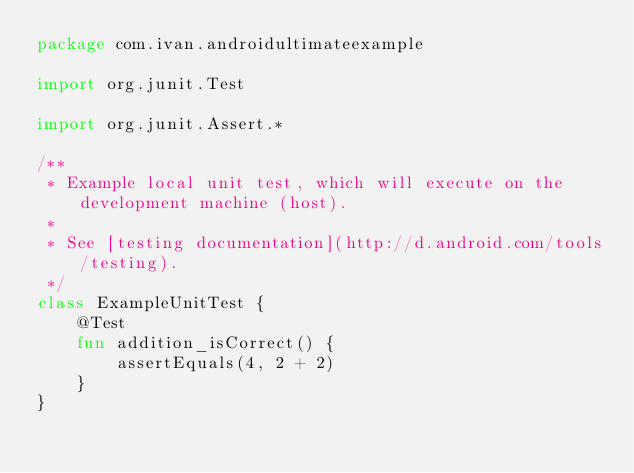<code> <loc_0><loc_0><loc_500><loc_500><_Kotlin_>package com.ivan.androidultimateexample

import org.junit.Test

import org.junit.Assert.*

/**
 * Example local unit test, which will execute on the development machine (host).
 *
 * See [testing documentation](http://d.android.com/tools/testing).
 */
class ExampleUnitTest {
    @Test
    fun addition_isCorrect() {
        assertEquals(4, 2 + 2)
    }
}
</code> 